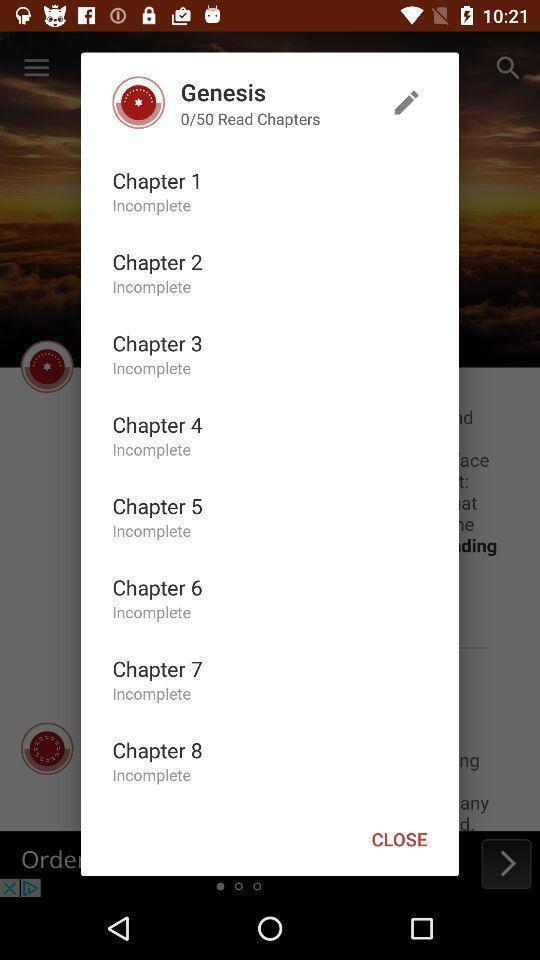Provide a textual representation of this image. Popup to select chapter in a holy book app. 